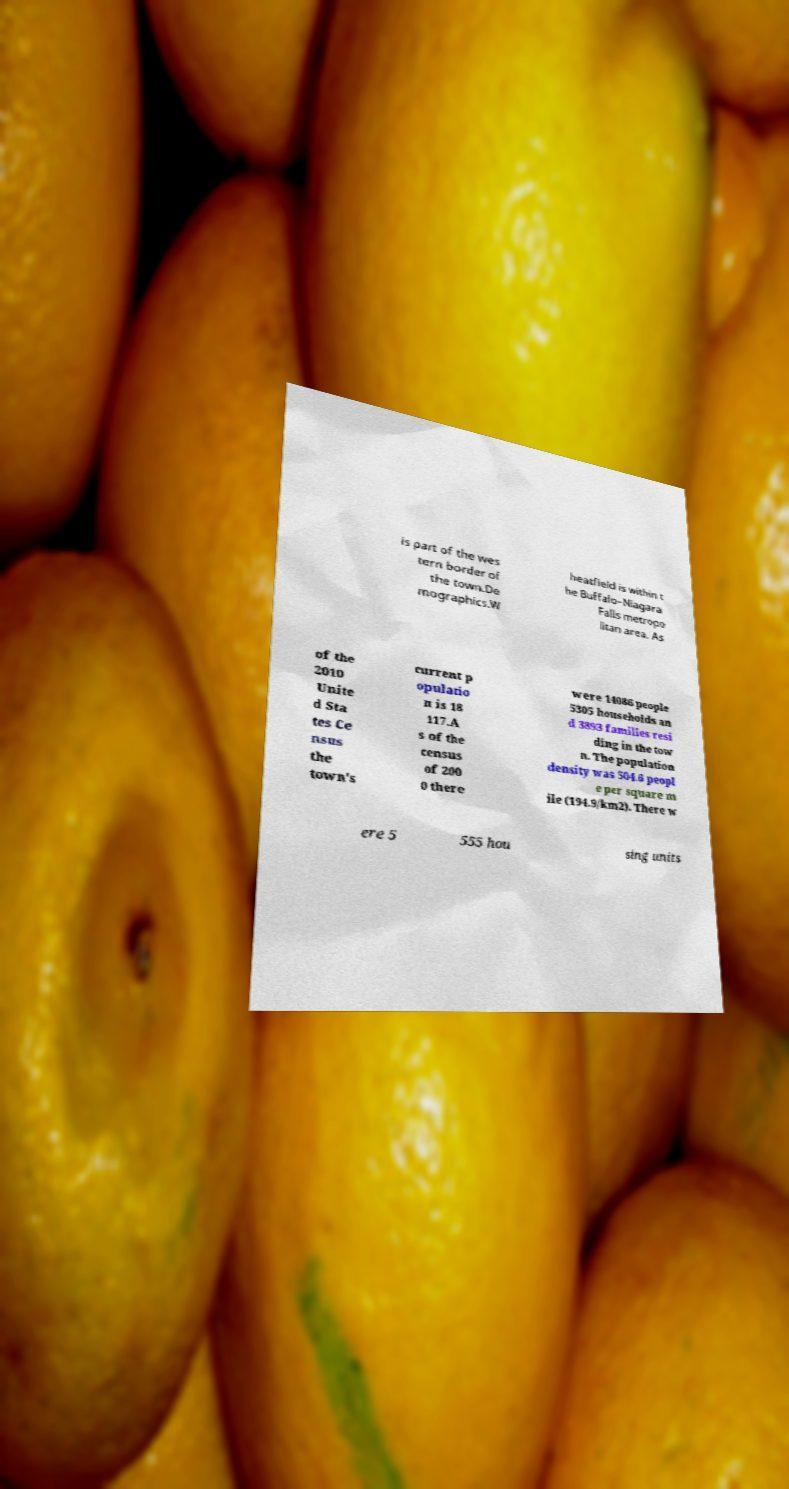Could you extract and type out the text from this image? is part of the wes tern border of the town.De mographics.W heatfield is within t he Buffalo–Niagara Falls metropo litan area. As of the 2010 Unite d Sta tes Ce nsus the town's current p opulatio n is 18 117.A s of the census of 200 0 there were 14086 people 5305 households an d 3893 families resi ding in the tow n. The population density was 504.6 peopl e per square m ile (194.9/km2). There w ere 5 555 hou sing units 